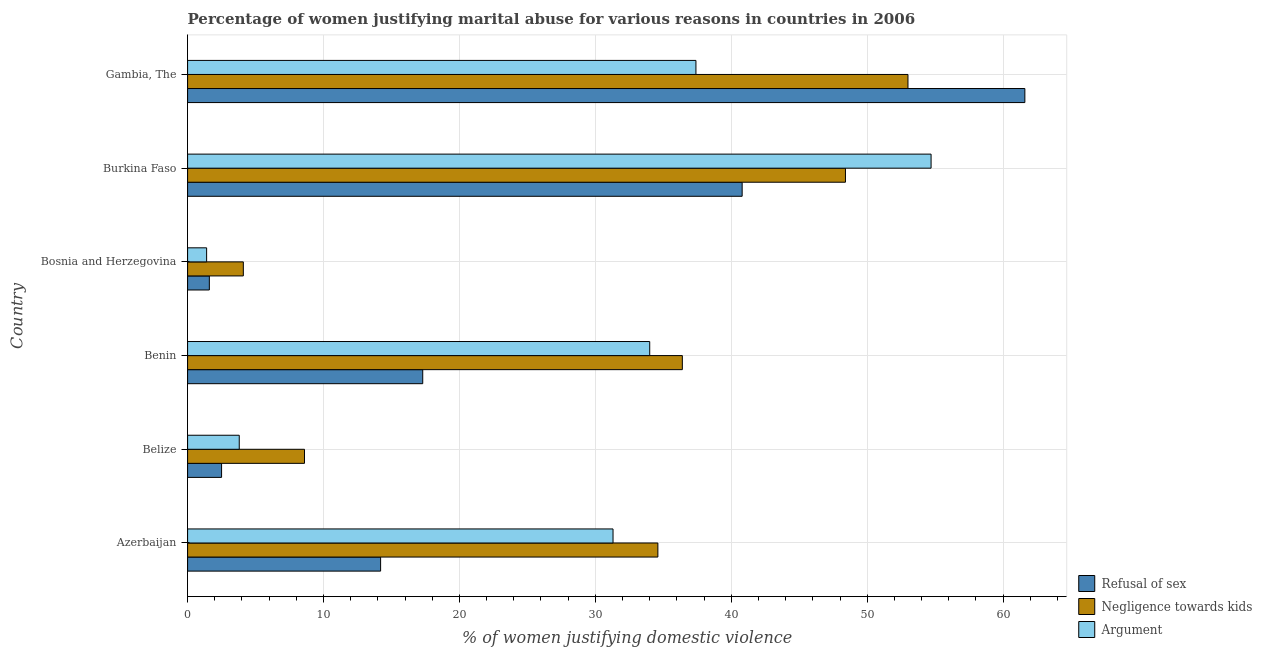Are the number of bars on each tick of the Y-axis equal?
Offer a terse response. Yes. How many bars are there on the 4th tick from the bottom?
Make the answer very short. 3. What is the label of the 5th group of bars from the top?
Your response must be concise. Belize. Across all countries, what is the maximum percentage of women justifying domestic violence due to refusal of sex?
Make the answer very short. 61.6. In which country was the percentage of women justifying domestic violence due to arguments maximum?
Keep it short and to the point. Burkina Faso. In which country was the percentage of women justifying domestic violence due to refusal of sex minimum?
Make the answer very short. Bosnia and Herzegovina. What is the total percentage of women justifying domestic violence due to negligence towards kids in the graph?
Offer a terse response. 185.1. What is the difference between the percentage of women justifying domestic violence due to arguments in Benin and that in Bosnia and Herzegovina?
Your answer should be compact. 32.6. What is the difference between the percentage of women justifying domestic violence due to refusal of sex in Gambia, The and the percentage of women justifying domestic violence due to arguments in Burkina Faso?
Keep it short and to the point. 6.9. What is the average percentage of women justifying domestic violence due to negligence towards kids per country?
Keep it short and to the point. 30.85. What is the ratio of the percentage of women justifying domestic violence due to refusal of sex in Belize to that in Burkina Faso?
Your answer should be compact. 0.06. What is the difference between the highest and the lowest percentage of women justifying domestic violence due to refusal of sex?
Your answer should be compact. 60. Is the sum of the percentage of women justifying domestic violence due to negligence towards kids in Azerbaijan and Benin greater than the maximum percentage of women justifying domestic violence due to arguments across all countries?
Provide a succinct answer. Yes. What does the 1st bar from the top in Burkina Faso represents?
Give a very brief answer. Argument. What does the 1st bar from the bottom in Belize represents?
Ensure brevity in your answer.  Refusal of sex. Is it the case that in every country, the sum of the percentage of women justifying domestic violence due to refusal of sex and percentage of women justifying domestic violence due to negligence towards kids is greater than the percentage of women justifying domestic violence due to arguments?
Give a very brief answer. Yes. How many bars are there?
Offer a terse response. 18. Are all the bars in the graph horizontal?
Provide a succinct answer. Yes. How many countries are there in the graph?
Your answer should be compact. 6. What is the difference between two consecutive major ticks on the X-axis?
Provide a succinct answer. 10. Are the values on the major ticks of X-axis written in scientific E-notation?
Your answer should be very brief. No. Does the graph contain any zero values?
Keep it short and to the point. No. How many legend labels are there?
Keep it short and to the point. 3. What is the title of the graph?
Provide a succinct answer. Percentage of women justifying marital abuse for various reasons in countries in 2006. Does "Transport" appear as one of the legend labels in the graph?
Offer a terse response. No. What is the label or title of the X-axis?
Give a very brief answer. % of women justifying domestic violence. What is the label or title of the Y-axis?
Your answer should be very brief. Country. What is the % of women justifying domestic violence in Negligence towards kids in Azerbaijan?
Give a very brief answer. 34.6. What is the % of women justifying domestic violence of Argument in Azerbaijan?
Ensure brevity in your answer.  31.3. What is the % of women justifying domestic violence of Argument in Belize?
Keep it short and to the point. 3.8. What is the % of women justifying domestic violence of Negligence towards kids in Benin?
Your answer should be very brief. 36.4. What is the % of women justifying domestic violence in Argument in Benin?
Make the answer very short. 34. What is the % of women justifying domestic violence of Negligence towards kids in Bosnia and Herzegovina?
Keep it short and to the point. 4.1. What is the % of women justifying domestic violence in Argument in Bosnia and Herzegovina?
Give a very brief answer. 1.4. What is the % of women justifying domestic violence of Refusal of sex in Burkina Faso?
Provide a succinct answer. 40.8. What is the % of women justifying domestic violence in Negligence towards kids in Burkina Faso?
Provide a succinct answer. 48.4. What is the % of women justifying domestic violence of Argument in Burkina Faso?
Offer a very short reply. 54.7. What is the % of women justifying domestic violence of Refusal of sex in Gambia, The?
Offer a very short reply. 61.6. What is the % of women justifying domestic violence in Argument in Gambia, The?
Provide a short and direct response. 37.4. Across all countries, what is the maximum % of women justifying domestic violence of Refusal of sex?
Offer a terse response. 61.6. Across all countries, what is the maximum % of women justifying domestic violence of Argument?
Your answer should be very brief. 54.7. Across all countries, what is the minimum % of women justifying domestic violence in Negligence towards kids?
Your answer should be very brief. 4.1. Across all countries, what is the minimum % of women justifying domestic violence in Argument?
Your response must be concise. 1.4. What is the total % of women justifying domestic violence in Refusal of sex in the graph?
Make the answer very short. 138. What is the total % of women justifying domestic violence in Negligence towards kids in the graph?
Your answer should be very brief. 185.1. What is the total % of women justifying domestic violence of Argument in the graph?
Offer a terse response. 162.6. What is the difference between the % of women justifying domestic violence of Negligence towards kids in Azerbaijan and that in Belize?
Offer a very short reply. 26. What is the difference between the % of women justifying domestic violence in Argument in Azerbaijan and that in Belize?
Provide a short and direct response. 27.5. What is the difference between the % of women justifying domestic violence in Refusal of sex in Azerbaijan and that in Bosnia and Herzegovina?
Offer a terse response. 12.6. What is the difference between the % of women justifying domestic violence in Negligence towards kids in Azerbaijan and that in Bosnia and Herzegovina?
Your answer should be very brief. 30.5. What is the difference between the % of women justifying domestic violence in Argument in Azerbaijan and that in Bosnia and Herzegovina?
Provide a short and direct response. 29.9. What is the difference between the % of women justifying domestic violence of Refusal of sex in Azerbaijan and that in Burkina Faso?
Give a very brief answer. -26.6. What is the difference between the % of women justifying domestic violence in Argument in Azerbaijan and that in Burkina Faso?
Keep it short and to the point. -23.4. What is the difference between the % of women justifying domestic violence of Refusal of sex in Azerbaijan and that in Gambia, The?
Offer a terse response. -47.4. What is the difference between the % of women justifying domestic violence in Negligence towards kids in Azerbaijan and that in Gambia, The?
Your answer should be very brief. -18.4. What is the difference between the % of women justifying domestic violence in Argument in Azerbaijan and that in Gambia, The?
Your answer should be compact. -6.1. What is the difference between the % of women justifying domestic violence of Refusal of sex in Belize and that in Benin?
Provide a succinct answer. -14.8. What is the difference between the % of women justifying domestic violence of Negligence towards kids in Belize and that in Benin?
Provide a succinct answer. -27.8. What is the difference between the % of women justifying domestic violence in Argument in Belize and that in Benin?
Provide a succinct answer. -30.2. What is the difference between the % of women justifying domestic violence in Refusal of sex in Belize and that in Bosnia and Herzegovina?
Your answer should be compact. 0.9. What is the difference between the % of women justifying domestic violence of Negligence towards kids in Belize and that in Bosnia and Herzegovina?
Offer a very short reply. 4.5. What is the difference between the % of women justifying domestic violence of Argument in Belize and that in Bosnia and Herzegovina?
Ensure brevity in your answer.  2.4. What is the difference between the % of women justifying domestic violence of Refusal of sex in Belize and that in Burkina Faso?
Provide a short and direct response. -38.3. What is the difference between the % of women justifying domestic violence of Negligence towards kids in Belize and that in Burkina Faso?
Your answer should be compact. -39.8. What is the difference between the % of women justifying domestic violence in Argument in Belize and that in Burkina Faso?
Your response must be concise. -50.9. What is the difference between the % of women justifying domestic violence in Refusal of sex in Belize and that in Gambia, The?
Offer a terse response. -59.1. What is the difference between the % of women justifying domestic violence in Negligence towards kids in Belize and that in Gambia, The?
Provide a succinct answer. -44.4. What is the difference between the % of women justifying domestic violence of Argument in Belize and that in Gambia, The?
Offer a terse response. -33.6. What is the difference between the % of women justifying domestic violence of Refusal of sex in Benin and that in Bosnia and Herzegovina?
Ensure brevity in your answer.  15.7. What is the difference between the % of women justifying domestic violence in Negligence towards kids in Benin and that in Bosnia and Herzegovina?
Offer a terse response. 32.3. What is the difference between the % of women justifying domestic violence in Argument in Benin and that in Bosnia and Herzegovina?
Provide a short and direct response. 32.6. What is the difference between the % of women justifying domestic violence in Refusal of sex in Benin and that in Burkina Faso?
Your response must be concise. -23.5. What is the difference between the % of women justifying domestic violence in Argument in Benin and that in Burkina Faso?
Your answer should be very brief. -20.7. What is the difference between the % of women justifying domestic violence of Refusal of sex in Benin and that in Gambia, The?
Give a very brief answer. -44.3. What is the difference between the % of women justifying domestic violence in Negligence towards kids in Benin and that in Gambia, The?
Your answer should be very brief. -16.6. What is the difference between the % of women justifying domestic violence in Refusal of sex in Bosnia and Herzegovina and that in Burkina Faso?
Offer a terse response. -39.2. What is the difference between the % of women justifying domestic violence of Negligence towards kids in Bosnia and Herzegovina and that in Burkina Faso?
Your answer should be compact. -44.3. What is the difference between the % of women justifying domestic violence in Argument in Bosnia and Herzegovina and that in Burkina Faso?
Offer a terse response. -53.3. What is the difference between the % of women justifying domestic violence of Refusal of sex in Bosnia and Herzegovina and that in Gambia, The?
Ensure brevity in your answer.  -60. What is the difference between the % of women justifying domestic violence of Negligence towards kids in Bosnia and Herzegovina and that in Gambia, The?
Your response must be concise. -48.9. What is the difference between the % of women justifying domestic violence in Argument in Bosnia and Herzegovina and that in Gambia, The?
Offer a very short reply. -36. What is the difference between the % of women justifying domestic violence in Refusal of sex in Burkina Faso and that in Gambia, The?
Offer a terse response. -20.8. What is the difference between the % of women justifying domestic violence in Negligence towards kids in Burkina Faso and that in Gambia, The?
Provide a short and direct response. -4.6. What is the difference between the % of women justifying domestic violence in Argument in Burkina Faso and that in Gambia, The?
Your answer should be compact. 17.3. What is the difference between the % of women justifying domestic violence in Refusal of sex in Azerbaijan and the % of women justifying domestic violence in Argument in Belize?
Your answer should be compact. 10.4. What is the difference between the % of women justifying domestic violence in Negligence towards kids in Azerbaijan and the % of women justifying domestic violence in Argument in Belize?
Ensure brevity in your answer.  30.8. What is the difference between the % of women justifying domestic violence in Refusal of sex in Azerbaijan and the % of women justifying domestic violence in Negligence towards kids in Benin?
Offer a very short reply. -22.2. What is the difference between the % of women justifying domestic violence in Refusal of sex in Azerbaijan and the % of women justifying domestic violence in Argument in Benin?
Provide a succinct answer. -19.8. What is the difference between the % of women justifying domestic violence of Negligence towards kids in Azerbaijan and the % of women justifying domestic violence of Argument in Bosnia and Herzegovina?
Offer a very short reply. 33.2. What is the difference between the % of women justifying domestic violence of Refusal of sex in Azerbaijan and the % of women justifying domestic violence of Negligence towards kids in Burkina Faso?
Your answer should be very brief. -34.2. What is the difference between the % of women justifying domestic violence in Refusal of sex in Azerbaijan and the % of women justifying domestic violence in Argument in Burkina Faso?
Offer a terse response. -40.5. What is the difference between the % of women justifying domestic violence in Negligence towards kids in Azerbaijan and the % of women justifying domestic violence in Argument in Burkina Faso?
Offer a very short reply. -20.1. What is the difference between the % of women justifying domestic violence in Refusal of sex in Azerbaijan and the % of women justifying domestic violence in Negligence towards kids in Gambia, The?
Provide a short and direct response. -38.8. What is the difference between the % of women justifying domestic violence in Refusal of sex in Azerbaijan and the % of women justifying domestic violence in Argument in Gambia, The?
Offer a terse response. -23.2. What is the difference between the % of women justifying domestic violence of Negligence towards kids in Azerbaijan and the % of women justifying domestic violence of Argument in Gambia, The?
Give a very brief answer. -2.8. What is the difference between the % of women justifying domestic violence in Refusal of sex in Belize and the % of women justifying domestic violence in Negligence towards kids in Benin?
Offer a terse response. -33.9. What is the difference between the % of women justifying domestic violence in Refusal of sex in Belize and the % of women justifying domestic violence in Argument in Benin?
Your answer should be very brief. -31.5. What is the difference between the % of women justifying domestic violence in Negligence towards kids in Belize and the % of women justifying domestic violence in Argument in Benin?
Ensure brevity in your answer.  -25.4. What is the difference between the % of women justifying domestic violence of Refusal of sex in Belize and the % of women justifying domestic violence of Negligence towards kids in Bosnia and Herzegovina?
Keep it short and to the point. -1.6. What is the difference between the % of women justifying domestic violence in Refusal of sex in Belize and the % of women justifying domestic violence in Argument in Bosnia and Herzegovina?
Give a very brief answer. 1.1. What is the difference between the % of women justifying domestic violence in Negligence towards kids in Belize and the % of women justifying domestic violence in Argument in Bosnia and Herzegovina?
Provide a short and direct response. 7.2. What is the difference between the % of women justifying domestic violence in Refusal of sex in Belize and the % of women justifying domestic violence in Negligence towards kids in Burkina Faso?
Keep it short and to the point. -45.9. What is the difference between the % of women justifying domestic violence of Refusal of sex in Belize and the % of women justifying domestic violence of Argument in Burkina Faso?
Give a very brief answer. -52.2. What is the difference between the % of women justifying domestic violence of Negligence towards kids in Belize and the % of women justifying domestic violence of Argument in Burkina Faso?
Make the answer very short. -46.1. What is the difference between the % of women justifying domestic violence of Refusal of sex in Belize and the % of women justifying domestic violence of Negligence towards kids in Gambia, The?
Your response must be concise. -50.5. What is the difference between the % of women justifying domestic violence of Refusal of sex in Belize and the % of women justifying domestic violence of Argument in Gambia, The?
Offer a terse response. -34.9. What is the difference between the % of women justifying domestic violence of Negligence towards kids in Belize and the % of women justifying domestic violence of Argument in Gambia, The?
Give a very brief answer. -28.8. What is the difference between the % of women justifying domestic violence of Refusal of sex in Benin and the % of women justifying domestic violence of Negligence towards kids in Bosnia and Herzegovina?
Make the answer very short. 13.2. What is the difference between the % of women justifying domestic violence in Refusal of sex in Benin and the % of women justifying domestic violence in Argument in Bosnia and Herzegovina?
Ensure brevity in your answer.  15.9. What is the difference between the % of women justifying domestic violence in Negligence towards kids in Benin and the % of women justifying domestic violence in Argument in Bosnia and Herzegovina?
Give a very brief answer. 35. What is the difference between the % of women justifying domestic violence in Refusal of sex in Benin and the % of women justifying domestic violence in Negligence towards kids in Burkina Faso?
Provide a succinct answer. -31.1. What is the difference between the % of women justifying domestic violence of Refusal of sex in Benin and the % of women justifying domestic violence of Argument in Burkina Faso?
Your answer should be very brief. -37.4. What is the difference between the % of women justifying domestic violence in Negligence towards kids in Benin and the % of women justifying domestic violence in Argument in Burkina Faso?
Offer a terse response. -18.3. What is the difference between the % of women justifying domestic violence in Refusal of sex in Benin and the % of women justifying domestic violence in Negligence towards kids in Gambia, The?
Give a very brief answer. -35.7. What is the difference between the % of women justifying domestic violence of Refusal of sex in Benin and the % of women justifying domestic violence of Argument in Gambia, The?
Provide a short and direct response. -20.1. What is the difference between the % of women justifying domestic violence of Refusal of sex in Bosnia and Herzegovina and the % of women justifying domestic violence of Negligence towards kids in Burkina Faso?
Offer a terse response. -46.8. What is the difference between the % of women justifying domestic violence in Refusal of sex in Bosnia and Herzegovina and the % of women justifying domestic violence in Argument in Burkina Faso?
Ensure brevity in your answer.  -53.1. What is the difference between the % of women justifying domestic violence in Negligence towards kids in Bosnia and Herzegovina and the % of women justifying domestic violence in Argument in Burkina Faso?
Keep it short and to the point. -50.6. What is the difference between the % of women justifying domestic violence in Refusal of sex in Bosnia and Herzegovina and the % of women justifying domestic violence in Negligence towards kids in Gambia, The?
Your answer should be compact. -51.4. What is the difference between the % of women justifying domestic violence in Refusal of sex in Bosnia and Herzegovina and the % of women justifying domestic violence in Argument in Gambia, The?
Keep it short and to the point. -35.8. What is the difference between the % of women justifying domestic violence of Negligence towards kids in Bosnia and Herzegovina and the % of women justifying domestic violence of Argument in Gambia, The?
Give a very brief answer. -33.3. What is the difference between the % of women justifying domestic violence in Refusal of sex in Burkina Faso and the % of women justifying domestic violence in Argument in Gambia, The?
Offer a very short reply. 3.4. What is the average % of women justifying domestic violence of Negligence towards kids per country?
Offer a terse response. 30.85. What is the average % of women justifying domestic violence in Argument per country?
Make the answer very short. 27.1. What is the difference between the % of women justifying domestic violence in Refusal of sex and % of women justifying domestic violence in Negligence towards kids in Azerbaijan?
Provide a succinct answer. -20.4. What is the difference between the % of women justifying domestic violence in Refusal of sex and % of women justifying domestic violence in Argument in Azerbaijan?
Your response must be concise. -17.1. What is the difference between the % of women justifying domestic violence of Negligence towards kids and % of women justifying domestic violence of Argument in Belize?
Your response must be concise. 4.8. What is the difference between the % of women justifying domestic violence in Refusal of sex and % of women justifying domestic violence in Negligence towards kids in Benin?
Your answer should be compact. -19.1. What is the difference between the % of women justifying domestic violence in Refusal of sex and % of women justifying domestic violence in Argument in Benin?
Provide a succinct answer. -16.7. What is the difference between the % of women justifying domestic violence in Refusal of sex and % of women justifying domestic violence in Negligence towards kids in Bosnia and Herzegovina?
Your answer should be compact. -2.5. What is the difference between the % of women justifying domestic violence of Refusal of sex and % of women justifying domestic violence of Argument in Bosnia and Herzegovina?
Your response must be concise. 0.2. What is the difference between the % of women justifying domestic violence in Refusal of sex and % of women justifying domestic violence in Negligence towards kids in Burkina Faso?
Make the answer very short. -7.6. What is the difference between the % of women justifying domestic violence in Negligence towards kids and % of women justifying domestic violence in Argument in Burkina Faso?
Offer a terse response. -6.3. What is the difference between the % of women justifying domestic violence of Refusal of sex and % of women justifying domestic violence of Argument in Gambia, The?
Make the answer very short. 24.2. What is the difference between the % of women justifying domestic violence in Negligence towards kids and % of women justifying domestic violence in Argument in Gambia, The?
Provide a succinct answer. 15.6. What is the ratio of the % of women justifying domestic violence of Refusal of sex in Azerbaijan to that in Belize?
Keep it short and to the point. 5.68. What is the ratio of the % of women justifying domestic violence in Negligence towards kids in Azerbaijan to that in Belize?
Offer a terse response. 4.02. What is the ratio of the % of women justifying domestic violence of Argument in Azerbaijan to that in Belize?
Ensure brevity in your answer.  8.24. What is the ratio of the % of women justifying domestic violence in Refusal of sex in Azerbaijan to that in Benin?
Provide a short and direct response. 0.82. What is the ratio of the % of women justifying domestic violence in Negligence towards kids in Azerbaijan to that in Benin?
Offer a terse response. 0.95. What is the ratio of the % of women justifying domestic violence in Argument in Azerbaijan to that in Benin?
Offer a terse response. 0.92. What is the ratio of the % of women justifying domestic violence of Refusal of sex in Azerbaijan to that in Bosnia and Herzegovina?
Keep it short and to the point. 8.88. What is the ratio of the % of women justifying domestic violence in Negligence towards kids in Azerbaijan to that in Bosnia and Herzegovina?
Keep it short and to the point. 8.44. What is the ratio of the % of women justifying domestic violence in Argument in Azerbaijan to that in Bosnia and Herzegovina?
Ensure brevity in your answer.  22.36. What is the ratio of the % of women justifying domestic violence in Refusal of sex in Azerbaijan to that in Burkina Faso?
Provide a short and direct response. 0.35. What is the ratio of the % of women justifying domestic violence in Negligence towards kids in Azerbaijan to that in Burkina Faso?
Provide a short and direct response. 0.71. What is the ratio of the % of women justifying domestic violence of Argument in Azerbaijan to that in Burkina Faso?
Provide a short and direct response. 0.57. What is the ratio of the % of women justifying domestic violence of Refusal of sex in Azerbaijan to that in Gambia, The?
Your answer should be very brief. 0.23. What is the ratio of the % of women justifying domestic violence of Negligence towards kids in Azerbaijan to that in Gambia, The?
Your answer should be very brief. 0.65. What is the ratio of the % of women justifying domestic violence of Argument in Azerbaijan to that in Gambia, The?
Your response must be concise. 0.84. What is the ratio of the % of women justifying domestic violence in Refusal of sex in Belize to that in Benin?
Offer a very short reply. 0.14. What is the ratio of the % of women justifying domestic violence of Negligence towards kids in Belize to that in Benin?
Provide a succinct answer. 0.24. What is the ratio of the % of women justifying domestic violence of Argument in Belize to that in Benin?
Provide a short and direct response. 0.11. What is the ratio of the % of women justifying domestic violence of Refusal of sex in Belize to that in Bosnia and Herzegovina?
Make the answer very short. 1.56. What is the ratio of the % of women justifying domestic violence in Negligence towards kids in Belize to that in Bosnia and Herzegovina?
Your answer should be compact. 2.1. What is the ratio of the % of women justifying domestic violence in Argument in Belize to that in Bosnia and Herzegovina?
Provide a short and direct response. 2.71. What is the ratio of the % of women justifying domestic violence of Refusal of sex in Belize to that in Burkina Faso?
Keep it short and to the point. 0.06. What is the ratio of the % of women justifying domestic violence of Negligence towards kids in Belize to that in Burkina Faso?
Give a very brief answer. 0.18. What is the ratio of the % of women justifying domestic violence in Argument in Belize to that in Burkina Faso?
Offer a very short reply. 0.07. What is the ratio of the % of women justifying domestic violence in Refusal of sex in Belize to that in Gambia, The?
Your answer should be very brief. 0.04. What is the ratio of the % of women justifying domestic violence of Negligence towards kids in Belize to that in Gambia, The?
Your answer should be very brief. 0.16. What is the ratio of the % of women justifying domestic violence of Argument in Belize to that in Gambia, The?
Ensure brevity in your answer.  0.1. What is the ratio of the % of women justifying domestic violence in Refusal of sex in Benin to that in Bosnia and Herzegovina?
Ensure brevity in your answer.  10.81. What is the ratio of the % of women justifying domestic violence of Negligence towards kids in Benin to that in Bosnia and Herzegovina?
Offer a very short reply. 8.88. What is the ratio of the % of women justifying domestic violence of Argument in Benin to that in Bosnia and Herzegovina?
Provide a short and direct response. 24.29. What is the ratio of the % of women justifying domestic violence in Refusal of sex in Benin to that in Burkina Faso?
Give a very brief answer. 0.42. What is the ratio of the % of women justifying domestic violence of Negligence towards kids in Benin to that in Burkina Faso?
Offer a terse response. 0.75. What is the ratio of the % of women justifying domestic violence in Argument in Benin to that in Burkina Faso?
Ensure brevity in your answer.  0.62. What is the ratio of the % of women justifying domestic violence in Refusal of sex in Benin to that in Gambia, The?
Your answer should be very brief. 0.28. What is the ratio of the % of women justifying domestic violence of Negligence towards kids in Benin to that in Gambia, The?
Keep it short and to the point. 0.69. What is the ratio of the % of women justifying domestic violence in Refusal of sex in Bosnia and Herzegovina to that in Burkina Faso?
Your answer should be compact. 0.04. What is the ratio of the % of women justifying domestic violence of Negligence towards kids in Bosnia and Herzegovina to that in Burkina Faso?
Provide a short and direct response. 0.08. What is the ratio of the % of women justifying domestic violence in Argument in Bosnia and Herzegovina to that in Burkina Faso?
Your response must be concise. 0.03. What is the ratio of the % of women justifying domestic violence of Refusal of sex in Bosnia and Herzegovina to that in Gambia, The?
Give a very brief answer. 0.03. What is the ratio of the % of women justifying domestic violence in Negligence towards kids in Bosnia and Herzegovina to that in Gambia, The?
Provide a succinct answer. 0.08. What is the ratio of the % of women justifying domestic violence of Argument in Bosnia and Herzegovina to that in Gambia, The?
Your answer should be very brief. 0.04. What is the ratio of the % of women justifying domestic violence of Refusal of sex in Burkina Faso to that in Gambia, The?
Provide a short and direct response. 0.66. What is the ratio of the % of women justifying domestic violence of Negligence towards kids in Burkina Faso to that in Gambia, The?
Provide a short and direct response. 0.91. What is the ratio of the % of women justifying domestic violence of Argument in Burkina Faso to that in Gambia, The?
Keep it short and to the point. 1.46. What is the difference between the highest and the second highest % of women justifying domestic violence in Refusal of sex?
Provide a short and direct response. 20.8. What is the difference between the highest and the second highest % of women justifying domestic violence in Negligence towards kids?
Make the answer very short. 4.6. What is the difference between the highest and the second highest % of women justifying domestic violence of Argument?
Your answer should be compact. 17.3. What is the difference between the highest and the lowest % of women justifying domestic violence of Refusal of sex?
Give a very brief answer. 60. What is the difference between the highest and the lowest % of women justifying domestic violence in Negligence towards kids?
Provide a short and direct response. 48.9. What is the difference between the highest and the lowest % of women justifying domestic violence in Argument?
Ensure brevity in your answer.  53.3. 